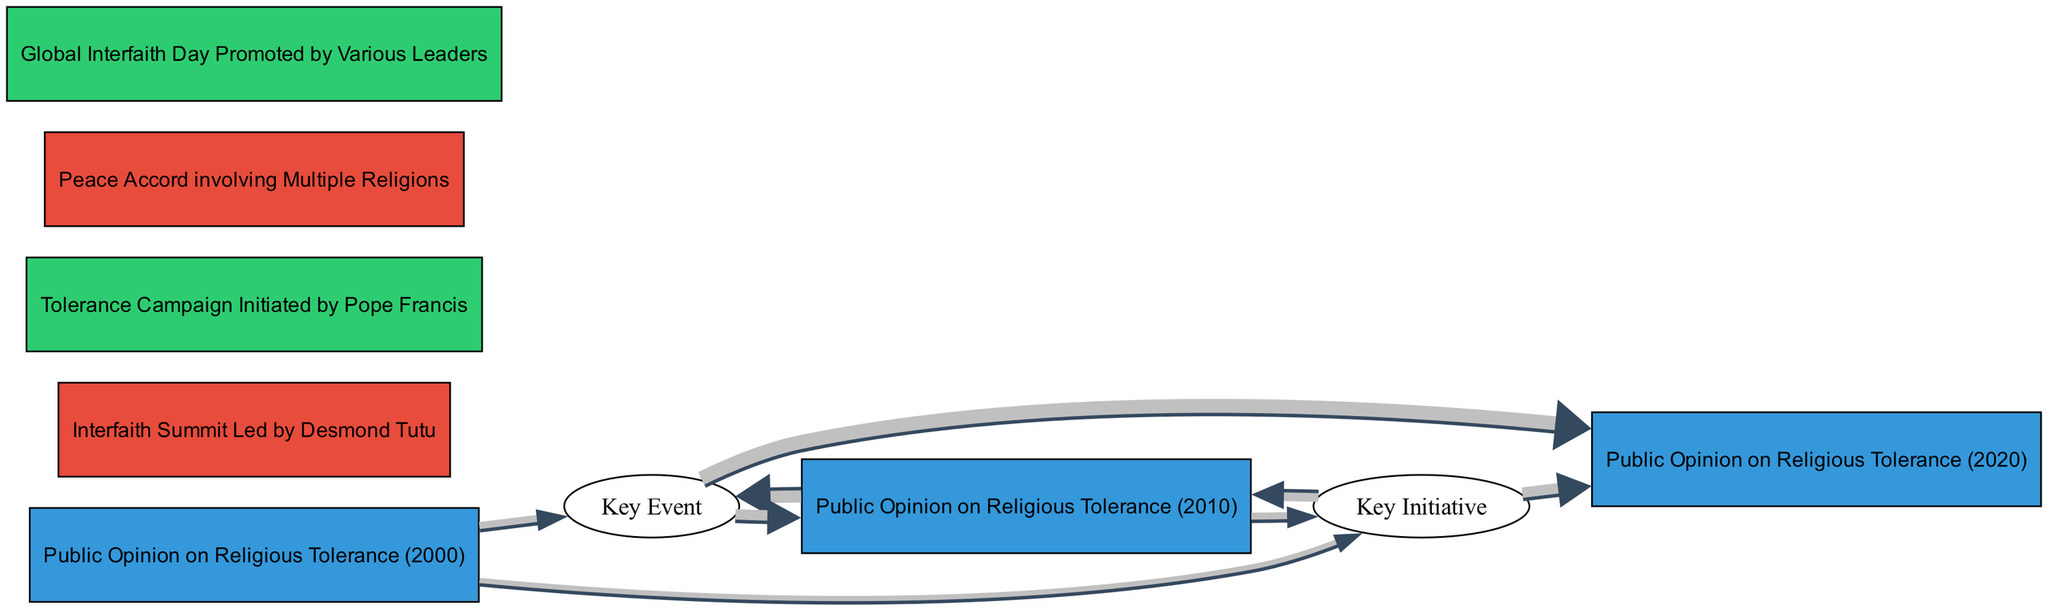What event is linked to public opinion in 2000? The diagram shows that the "Public Opinion on Religious Tolerance (2000)" is connected to the "Interfaith Summit Led by Desmond Tutu" with a value of 20.
Answer: Interfaith Summit Led by Desmond Tutu What is the connection value between the Tolerance Campaign 2006 and public opinion in 2010? The link from "Key Initiative: Tolerance Campaign 2006" to "Public Opinion on Religious Tolerance (2010)" has a value of 25.
Answer: 25 How many nodes are there in the diagram? By counting the unique elements listed as nodes, there are a total of 7 nodes in the diagram.
Answer: 7 What was the highest connection value leading to public opinion in 2020? The highest connection to "Public Opinion on Religious Tolerance (2020)" comes from the "Key Event: Peace Accord Signing 2015," with a value of 40.
Answer: 40 Which key initiative is associated with public opinion in 2010? The link from "Public Opinion on Religious Tolerance (2010)" to "Key Initiative: Global Interfaith Day 2019" indicates this association, with a connection value of 20.
Answer: Global Interfaith Day 2019 Between which years did public opinion show a notable increase directly after a specific event? The diagram shows that public opinion increased after the "Key Event: Peace Accord Signing 2015," moving from 2010 to 2020 with the highest connection value of 40.
Answer: 2010 to 2020 What is the total connection value of public opinion in 2010? To find this, we add the values of its incoming connections: 30 (from the Interfaith Summit) and 25 (from the Tolerance Campaign), resulting in a total of 55.
Answer: 55 What group does the "Global Interfaith Day Promoted by Various Leaders" belong to? The node is categorized as an initiative on the diagram, explicitly labeled in the group section.
Answer: initiatives What was the influence of the "Interfaith Summit Led by Desmond Tutu" on the public opinion in 2010? The summit had a direct influence with a connection value of 30 to public opinion in 2010, indicating a significant positive impact on public perceptions at that time.
Answer: 30 